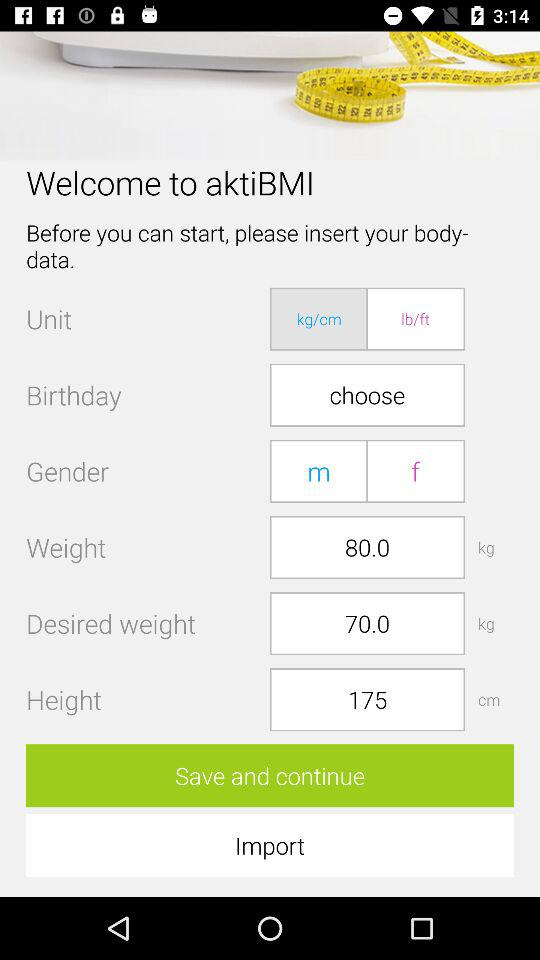Which gender has been selected?
When the provided information is insufficient, respond with <no answer>. <no answer> 